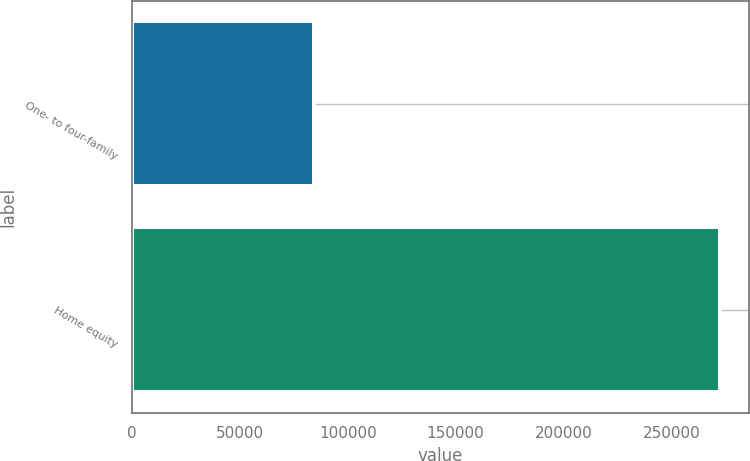Convert chart to OTSL. <chart><loc_0><loc_0><loc_500><loc_500><bar_chart><fcel>One- to four-family<fcel>Home equity<nl><fcel>84492<fcel>272475<nl></chart> 